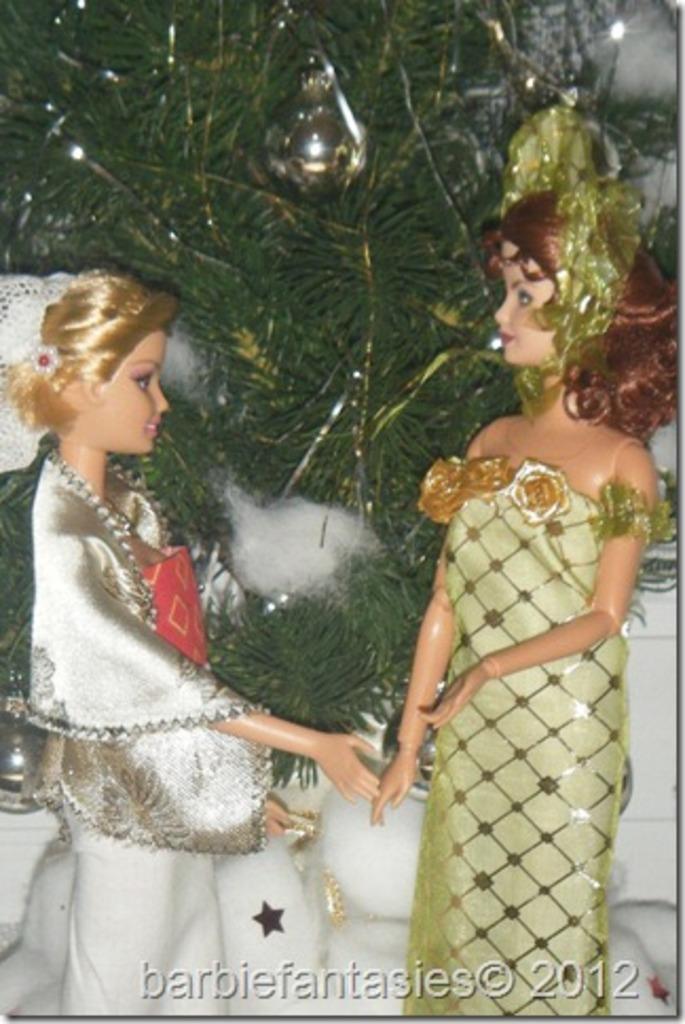In one or two sentences, can you explain what this image depicts? In this image I can see two dressed Barbie girls. In the background few leaves are visible. At the bottom of the image I can see some text. 